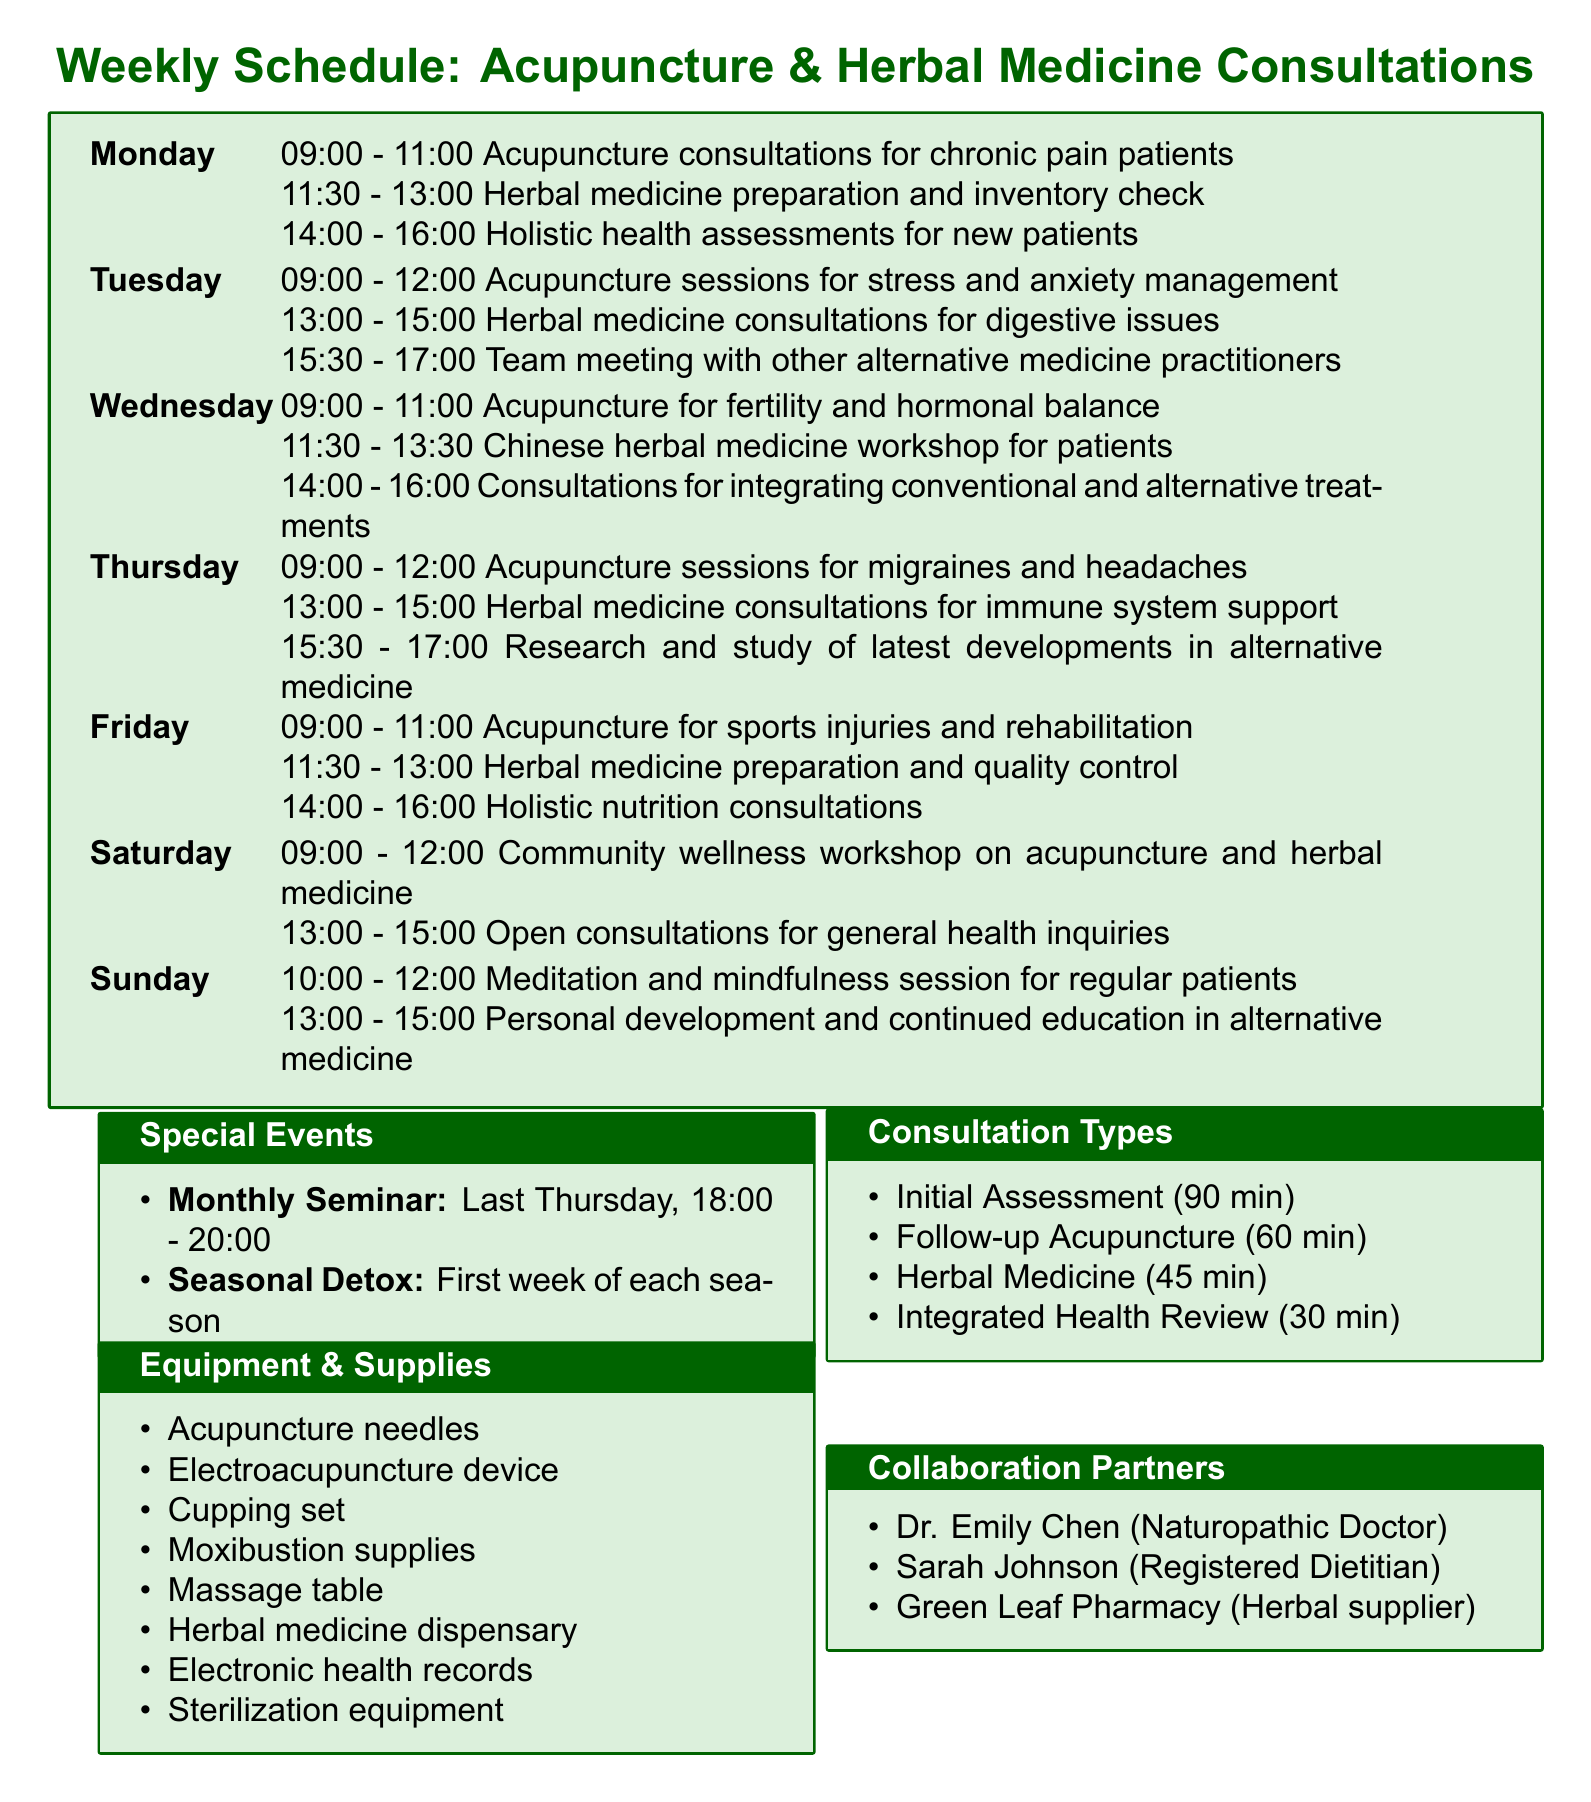What is scheduled on Mondays at 14:00? The document lists holistic health assessments for new patients scheduled from 14:00 to 16:00 on Mondays.
Answer: Holistic health assessments for new patients What type of herbal consultations occur on Tuesdays? The document specifies that herbal medicine consultations for digestive issues are scheduled on Tuesdays from 13:00 to 15:00.
Answer: Herbal medicine consultations for digestive issues How long is an initial holistic health assessment? The duration of an initial holistic health assessment mentioned in the document is 90 minutes.
Answer: 90 minutes What is the frequency of the monthly seminar? The document indicates that the monthly acupuncture and herbal medicine seminar occurs on the last Thursday of every month.
Answer: Last Thursday of every month Which day has a community wellness workshop? According to the schedule, the community wellness workshop on acupuncture and herbal medicine is scheduled for Saturday.
Answer: Saturday Who is the collaboration partner specializing in nutrition? The document names Sarah Johnson as the registered dietitian collaborating on nutritional support for patients.
Answer: Sarah Johnson What is the purpose of the Seasonal Detox Program? The seasonal detox program combines acupuncture, herbal medicine, and dietary recommendations as indicated in the document.
Answer: Guided cleanse combining acupuncture, herbal medicine, and dietary recommendations When do meditation sessions take place? The meditation and mindfulness sessions for regular patients are scheduled on Sundays from 10:00 to 12:00.
Answer: Sundays from 10:00 to 12:00 What equipment is listed for moxibustion? The document lists moxibustion supplies as part of the equipment and supplies used in the consultations.
Answer: Moxibustion supplies 